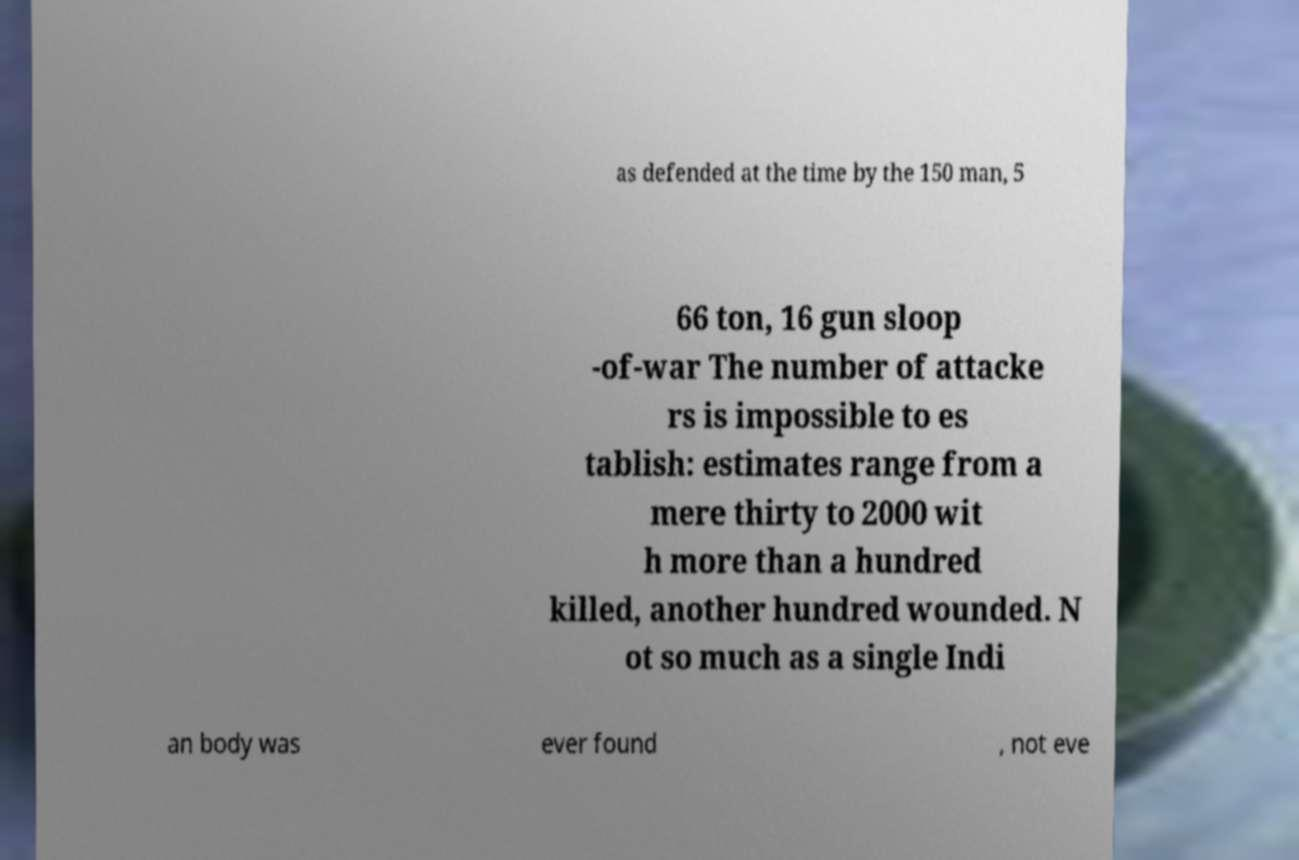Can you accurately transcribe the text from the provided image for me? as defended at the time by the 150 man, 5 66 ton, 16 gun sloop -of-war The number of attacke rs is impossible to es tablish: estimates range from a mere thirty to 2000 wit h more than a hundred killed, another hundred wounded. N ot so much as a single Indi an body was ever found , not eve 